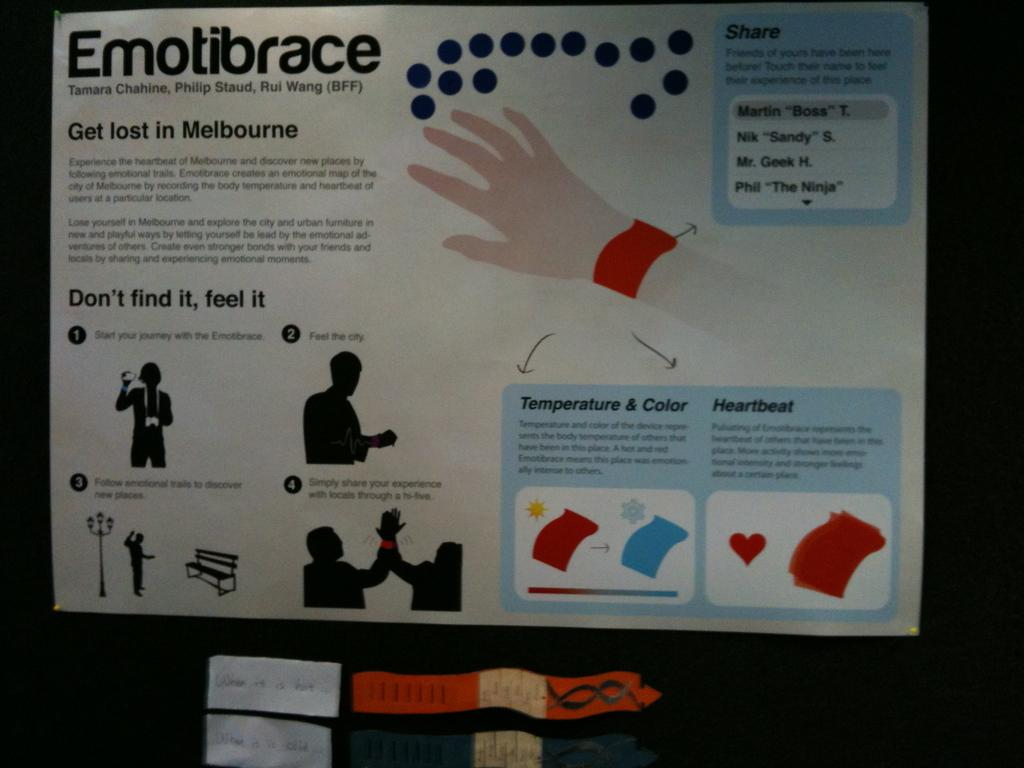<image>
Summarize the visual content of the image. a poster with a lot of information is titled Emotibrace 